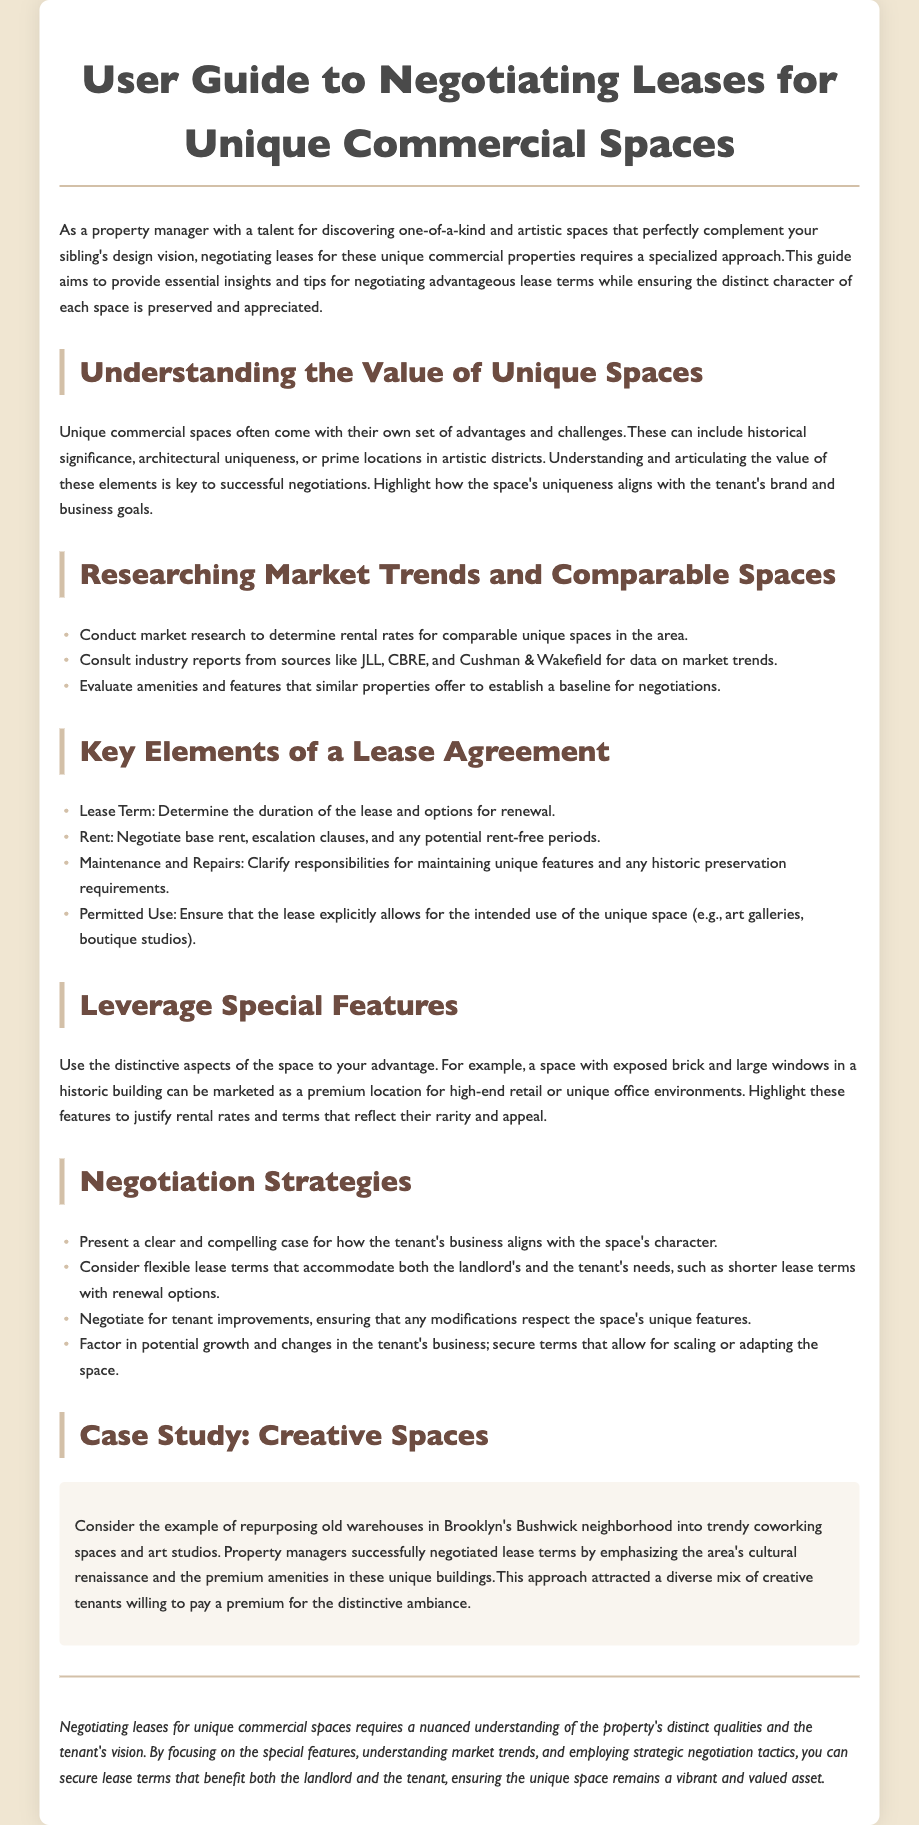What is the title of the guide? The title of the guide is clearly stated at the top of the document.
Answer: User Guide to Negotiating Leases for Unique Commercial Spaces What is a key element of a lease agreement? The document lists several key elements of a lease agreement, including specific examples.
Answer: Rent What should be emphasized to appeal to potential tenants? The guide suggests specific strategies for appealing to tenants, focusing on unique traits of the space.
Answer: Distinctive aspects Which area has been successfully repurposed according to the case study? The case study provides a specific location as an example of successful repurposing.
Answer: Bushwick What type of spaces does the guide focus on? The guide specifies the type of spaces recommended for negotiation in the lease terms.
Answer: Unique commercial spaces What is the main purpose of the guide? The introduction outlines the primary intent of the document to aid in a specific area of property management.
Answer: To provide essential insights and tips for negotiating leases How should one approach negotiation according to the document? The negotiation strategies section gives explicit methods for negotiation tailored to unique spaces.
Answer: Present a clear and compelling case What should be determined alongside lease term? The document emphasizes the importance of specific elements in lease agreements, including duration-related information.
Answer: Options for renewal 